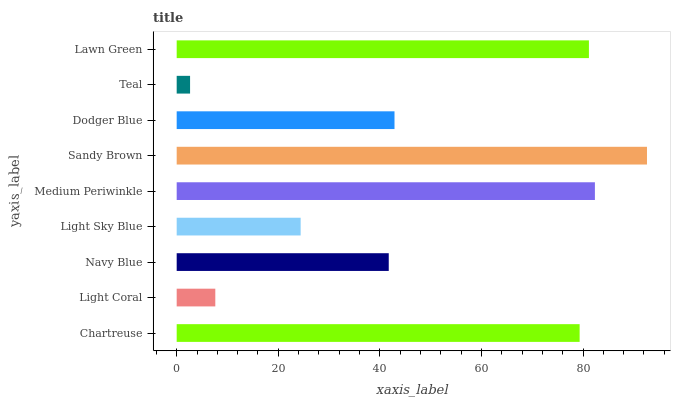Is Teal the minimum?
Answer yes or no. Yes. Is Sandy Brown the maximum?
Answer yes or no. Yes. Is Light Coral the minimum?
Answer yes or no. No. Is Light Coral the maximum?
Answer yes or no. No. Is Chartreuse greater than Light Coral?
Answer yes or no. Yes. Is Light Coral less than Chartreuse?
Answer yes or no. Yes. Is Light Coral greater than Chartreuse?
Answer yes or no. No. Is Chartreuse less than Light Coral?
Answer yes or no. No. Is Dodger Blue the high median?
Answer yes or no. Yes. Is Dodger Blue the low median?
Answer yes or no. Yes. Is Sandy Brown the high median?
Answer yes or no. No. Is Navy Blue the low median?
Answer yes or no. No. 